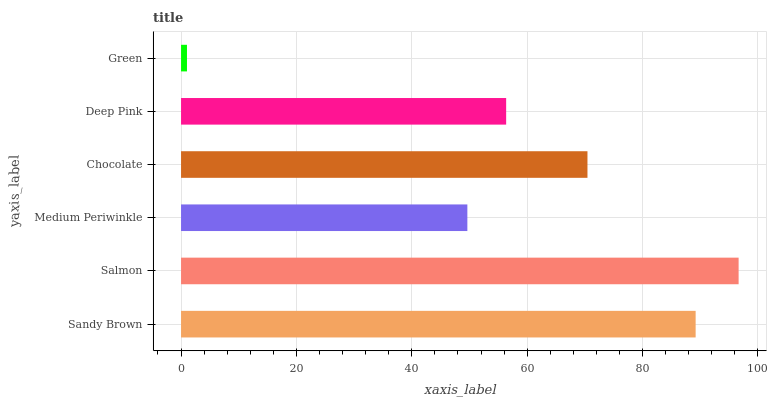Is Green the minimum?
Answer yes or no. Yes. Is Salmon the maximum?
Answer yes or no. Yes. Is Medium Periwinkle the minimum?
Answer yes or no. No. Is Medium Periwinkle the maximum?
Answer yes or no. No. Is Salmon greater than Medium Periwinkle?
Answer yes or no. Yes. Is Medium Periwinkle less than Salmon?
Answer yes or no. Yes. Is Medium Periwinkle greater than Salmon?
Answer yes or no. No. Is Salmon less than Medium Periwinkle?
Answer yes or no. No. Is Chocolate the high median?
Answer yes or no. Yes. Is Deep Pink the low median?
Answer yes or no. Yes. Is Salmon the high median?
Answer yes or no. No. Is Salmon the low median?
Answer yes or no. No. 